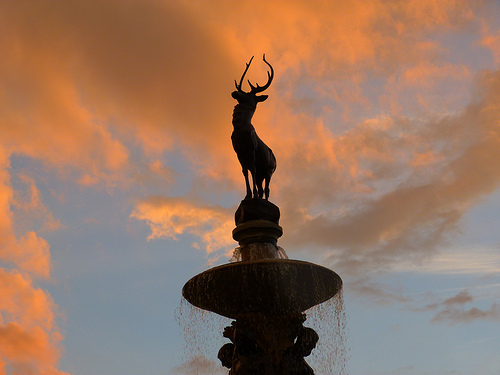<image>
Is there a deer sculpture under the clouds? Yes. The deer sculpture is positioned underneath the clouds, with the clouds above it in the vertical space. 